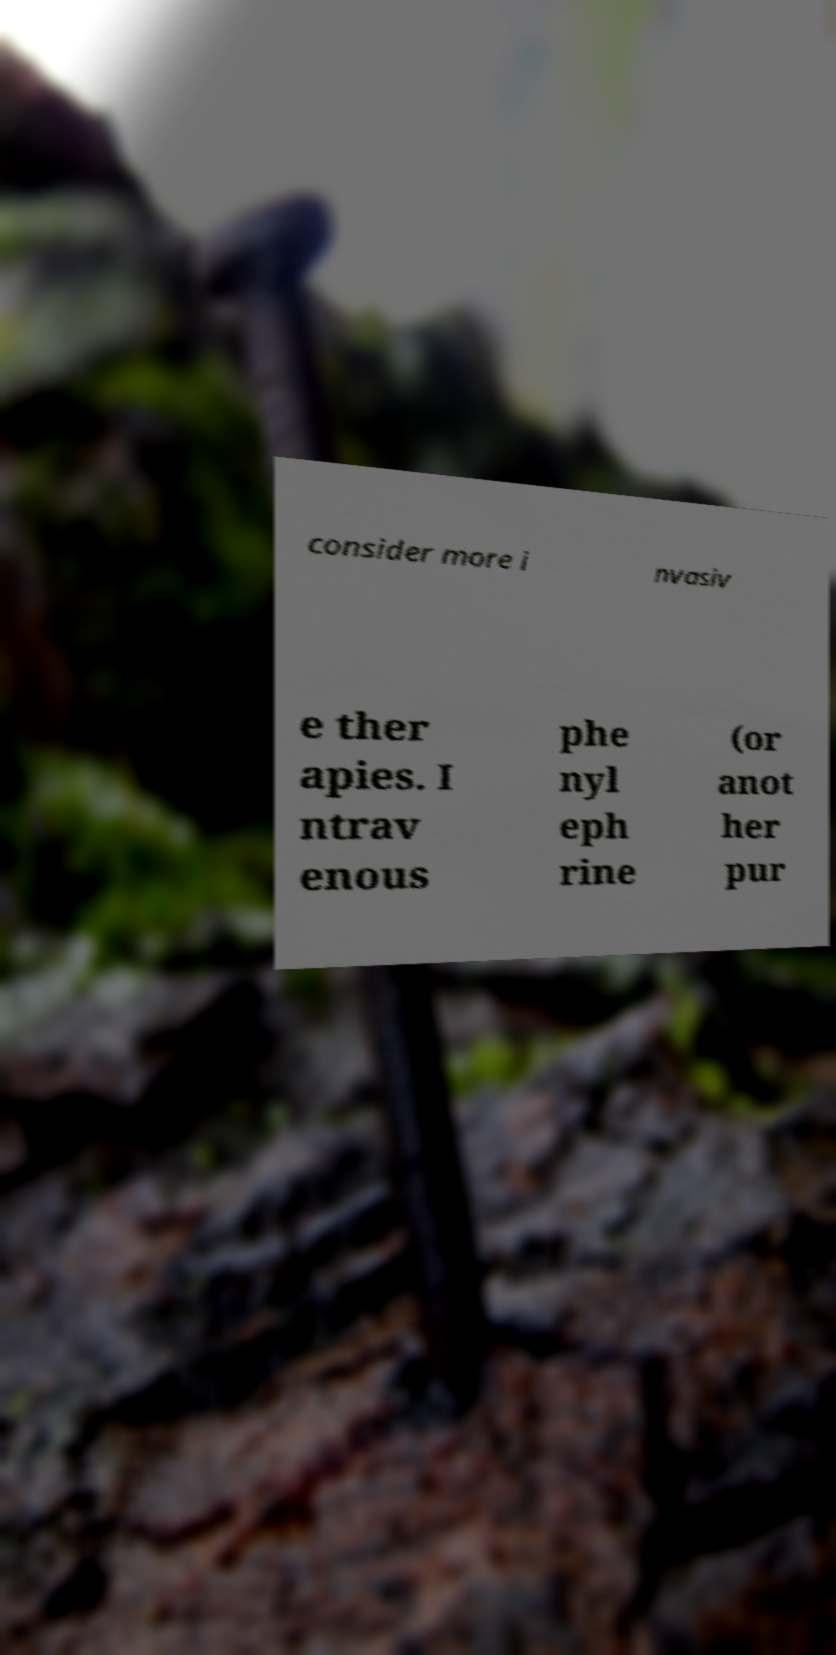Could you extract and type out the text from this image? consider more i nvasiv e ther apies. I ntrav enous phe nyl eph rine (or anot her pur 